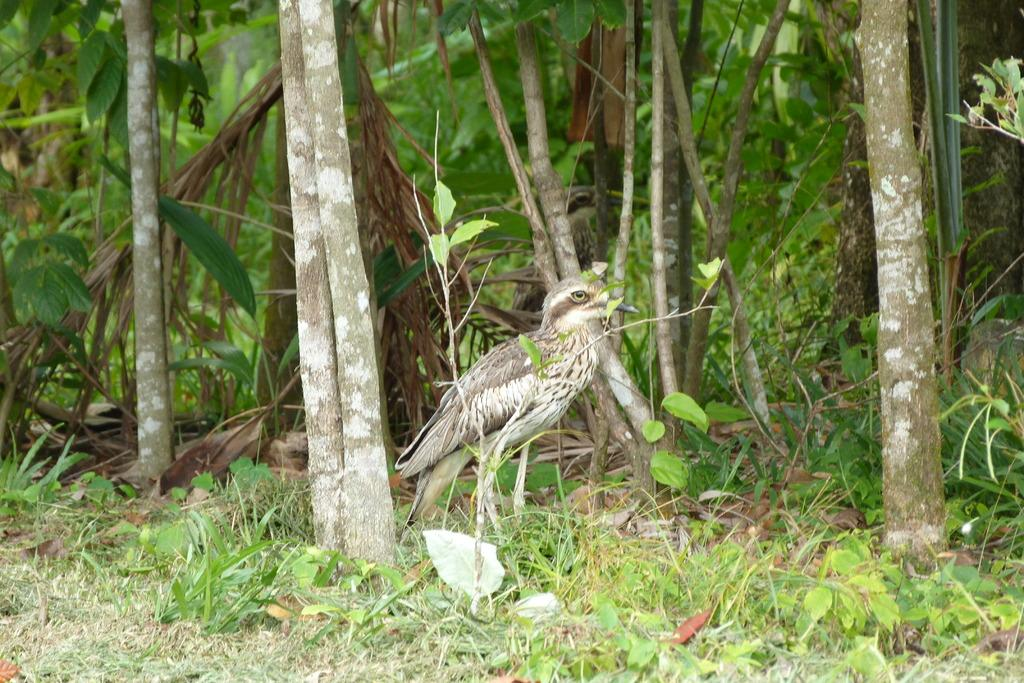What is the main subject of the image? There is a bird standing in the middle of the image. What type of natural environment is depicted in the image? There are trees and grass visible in the image. What type of tent can be seen in the background of the image? There is no tent present in the image; it features a bird standing in a natural environment with trees and grass. How does the bird use the pencil in the image? There is no pencil present in the image, as it only features a bird standing in a natural environment with trees and grass. 